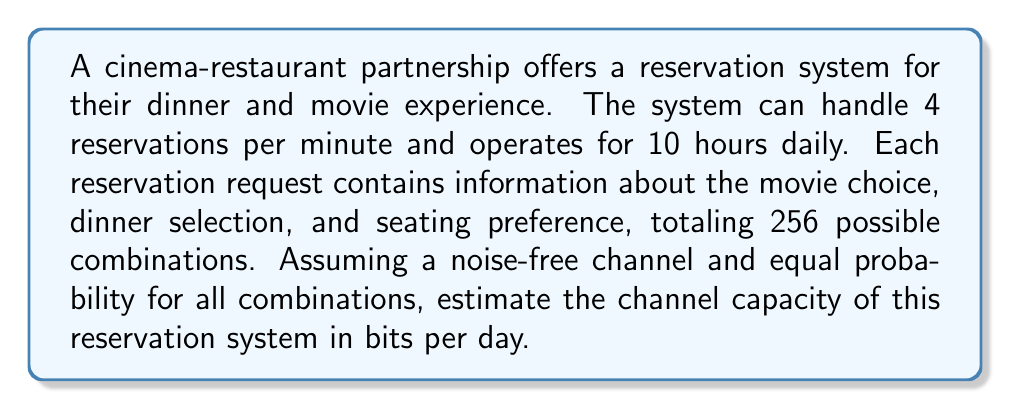Provide a solution to this math problem. To solve this problem, we'll use the channel capacity formula from information theory and apply it to the given scenario. Let's break it down step-by-step:

1) First, we need to calculate the information content of each reservation:
   With 256 possible combinations, we can calculate the information content as:
   $I = \log_2(256) = 8$ bits per reservation

2) Now, let's calculate the number of reservations the system can handle per day:
   - System operates for 10 hours = 600 minutes
   - 4 reservations per minute
   - Total reservations per day = $600 \times 4 = 2400$ reservations

3) The channel capacity formula is:
   $C = B \times \log_2(1 + \frac{S}{N})$
   Where:
   $C$ is the channel capacity in bits per second
   $B$ is the bandwidth (in this case, reservations per second)
   $S$ is the signal power
   $N$ is the noise power

4) In this case, we have a noise-free channel, so $\frac{S}{N} \to \infty$, simplifying our calculation to:
   $C = B \times I$
   Where $I$ is the information content per reservation

5) Let's calculate the bandwidth in reservations per second:
   $B = \frac{4 \text{ reservations}}{\text{60 seconds}} = \frac{1}{15}$ reservations/second

6) Now we can calculate the channel capacity:
   $C = \frac{1}{15} \times 8 = \frac{8}{15}$ bits/second

7) To get the capacity per day, we multiply by the number of seconds in 10 hours:
   $C_{day} = \frac{8}{15} \times (10 \times 3600) = 19200$ bits/day

Therefore, the channel capacity of the reservation system is 19200 bits per day.
Answer: 19200 bits per day 